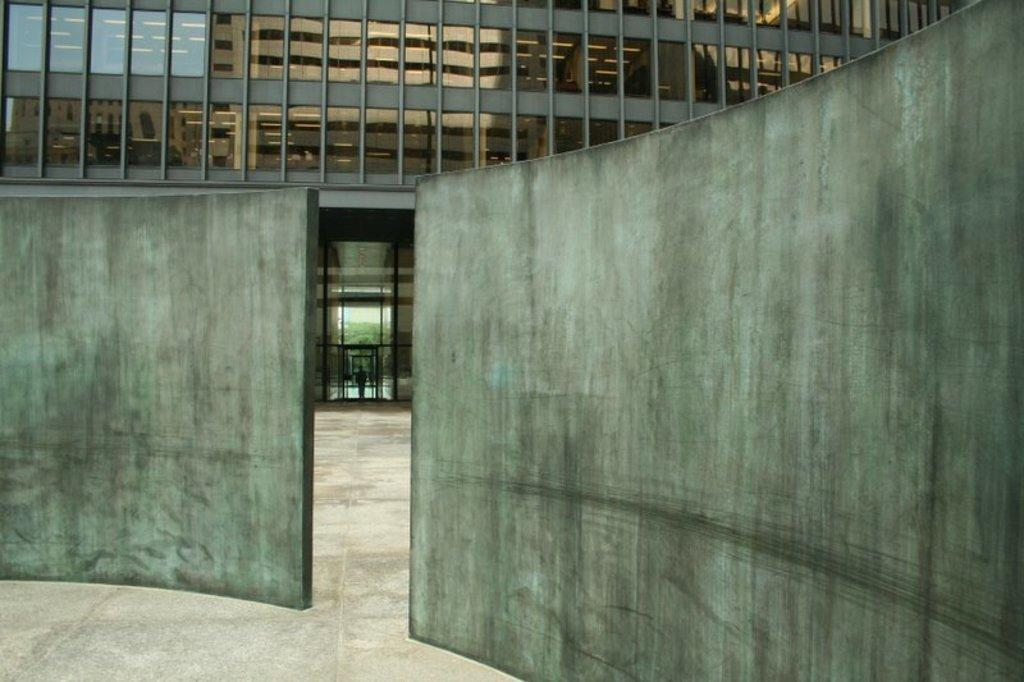What is a prominent feature in the image? There is a wall in the image. What can be inferred about the wall? The wall is part of a building. What type of windows are on the building? The building has glass windows. What can be seen on the glass windows? There is a reflection of another building on the glass windows. How many apples are on the wall in the image? There are no apples present in the image. What type of glass is used for the windows? The facts provided do not specify the type of glass used for the windows. --- Facts: 1. There is a person in the image. 2. The person is wearing a hat. 3. The person is holding a book. 4. The background of the image is a park. Absurd Topics: lion Conversation: Who or what is the main subject in the image? The main subject in the image is a person. What is the person wearing in the image? The person is wearing a hat. What is the person holding in the image? The person is holding a book. What can be seen in the background of the image? The background of the image is a park. Reasoning: Let's think step by step in order to produce the conversation. We start by identifying the main subject of the image, which is a person. Next, we describe specific features of the person, such as the hat. Then, we observe the actions of the person, noting that they are holding a book. Finally, we describe the background of the image, which is a park. We avoid yes/no questions and ensure that the language is simple and clear. Absurd Question/Answer: Can you see a lion in the image? No, there is no lion present in the image. 